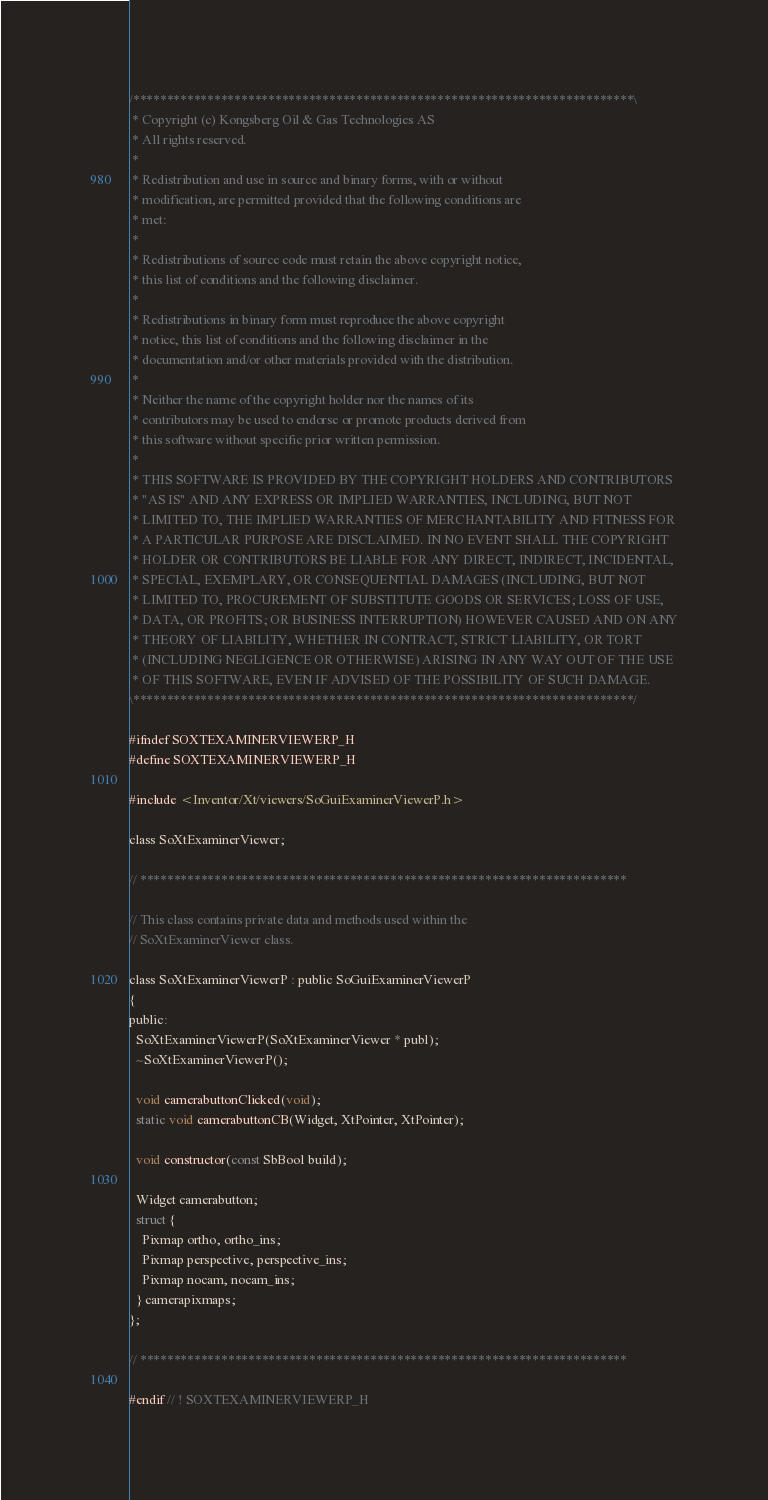<code> <loc_0><loc_0><loc_500><loc_500><_C_>/**************************************************************************\
 * Copyright (c) Kongsberg Oil & Gas Technologies AS
 * All rights reserved.
 * 
 * Redistribution and use in source and binary forms, with or without
 * modification, are permitted provided that the following conditions are
 * met:
 * 
 * Redistributions of source code must retain the above copyright notice,
 * this list of conditions and the following disclaimer.
 * 
 * Redistributions in binary form must reproduce the above copyright
 * notice, this list of conditions and the following disclaimer in the
 * documentation and/or other materials provided with the distribution.
 * 
 * Neither the name of the copyright holder nor the names of its
 * contributors may be used to endorse or promote products derived from
 * this software without specific prior written permission.
 * 
 * THIS SOFTWARE IS PROVIDED BY THE COPYRIGHT HOLDERS AND CONTRIBUTORS
 * "AS IS" AND ANY EXPRESS OR IMPLIED WARRANTIES, INCLUDING, BUT NOT
 * LIMITED TO, THE IMPLIED WARRANTIES OF MERCHANTABILITY AND FITNESS FOR
 * A PARTICULAR PURPOSE ARE DISCLAIMED. IN NO EVENT SHALL THE COPYRIGHT
 * HOLDER OR CONTRIBUTORS BE LIABLE FOR ANY DIRECT, INDIRECT, INCIDENTAL,
 * SPECIAL, EXEMPLARY, OR CONSEQUENTIAL DAMAGES (INCLUDING, BUT NOT
 * LIMITED TO, PROCUREMENT OF SUBSTITUTE GOODS OR SERVICES; LOSS OF USE,
 * DATA, OR PROFITS; OR BUSINESS INTERRUPTION) HOWEVER CAUSED AND ON ANY
 * THEORY OF LIABILITY, WHETHER IN CONTRACT, STRICT LIABILITY, OR TORT
 * (INCLUDING NEGLIGENCE OR OTHERWISE) ARISING IN ANY WAY OUT OF THE USE
 * OF THIS SOFTWARE, EVEN IF ADVISED OF THE POSSIBILITY OF SUCH DAMAGE.
\**************************************************************************/

#ifndef SOXTEXAMINERVIEWERP_H
#define SOXTEXAMINERVIEWERP_H

#include <Inventor/Xt/viewers/SoGuiExaminerViewerP.h>

class SoXtExaminerViewer;

// ************************************************************************

// This class contains private data and methods used within the
// SoXtExaminerViewer class.

class SoXtExaminerViewerP : public SoGuiExaminerViewerP
{
public:
  SoXtExaminerViewerP(SoXtExaminerViewer * publ);
  ~SoXtExaminerViewerP();

  void camerabuttonClicked(void);
  static void camerabuttonCB(Widget, XtPointer, XtPointer);

  void constructor(const SbBool build);

  Widget camerabutton;
  struct {
    Pixmap ortho, ortho_ins;
    Pixmap perspective, perspective_ins;
    Pixmap nocam, nocam_ins;
  } camerapixmaps;
};

// ************************************************************************

#endif // ! SOXTEXAMINERVIEWERP_H
</code> 